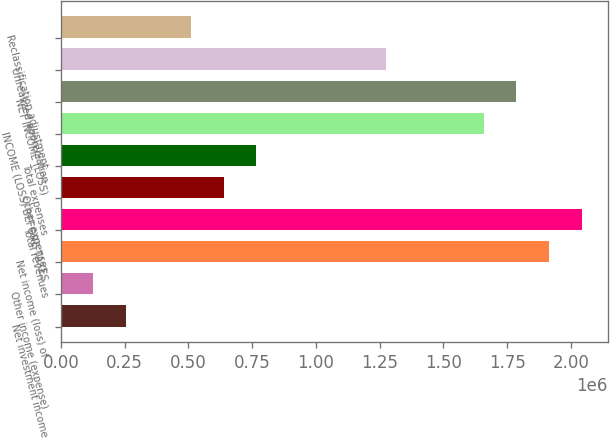Convert chart. <chart><loc_0><loc_0><loc_500><loc_500><bar_chart><fcel>Net investment income<fcel>Other income (expense)<fcel>Net income (loss) of<fcel>Total revenues<fcel>Other expenses<fcel>Total expenses<fcel>INCOME (LOSS) BEFORE TAXES<fcel>NET INCOME (LOSS)<fcel>Unrealized appreciation<fcel>Reclassification adjustment<nl><fcel>255337<fcel>127749<fcel>1.91397e+06<fcel>2.04156e+06<fcel>638098<fcel>765686<fcel>1.6588e+06<fcel>1.78638e+06<fcel>1.27604e+06<fcel>510511<nl></chart> 